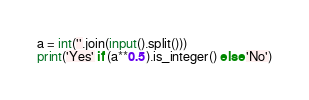Convert code to text. <code><loc_0><loc_0><loc_500><loc_500><_Python_>a = int(''.join(input().split()))
print('Yes' if (a**0.5).is_integer() else 'No')</code> 